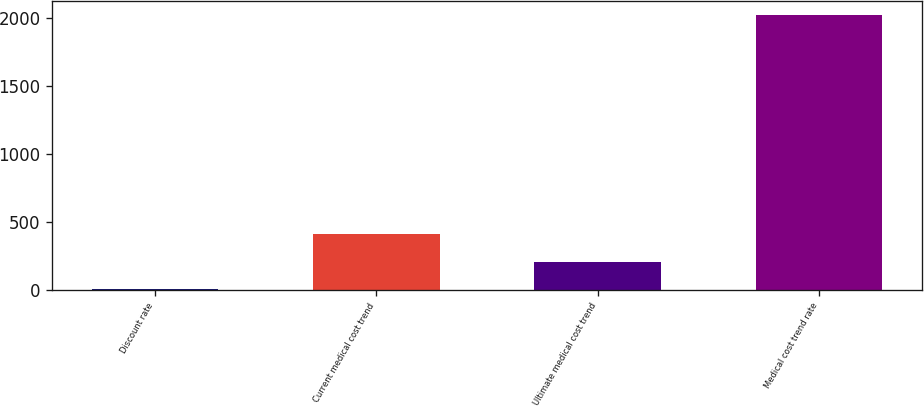Convert chart. <chart><loc_0><loc_0><loc_500><loc_500><bar_chart><fcel>Discount rate<fcel>Current medical cost trend<fcel>Ultimate medical cost trend<fcel>Medical cost trend rate<nl><fcel>4.6<fcel>407.88<fcel>206.24<fcel>2021<nl></chart> 